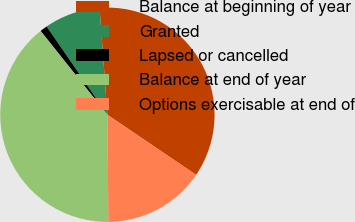Convert chart. <chart><loc_0><loc_0><loc_500><loc_500><pie_chart><fcel>Balance at beginning of year<fcel>Granted<fcel>Lapsed or cancelled<fcel>Balance at end of year<fcel>Options exercisable at end of<nl><fcel>35.64%<fcel>8.43%<fcel>1.12%<fcel>39.44%<fcel>15.37%<nl></chart> 